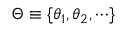<formula> <loc_0><loc_0><loc_500><loc_500>\boldsymbol \Theta \equiv \{ \boldsymbol \theta _ { 1 } , \boldsymbol \theta _ { 2 } , \cdots \}</formula> 